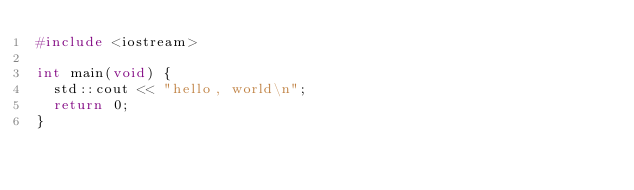Convert code to text. <code><loc_0><loc_0><loc_500><loc_500><_C++_>#include <iostream>

int main(void) {
	std::cout << "hello, world\n";
	return 0;
}
</code> 